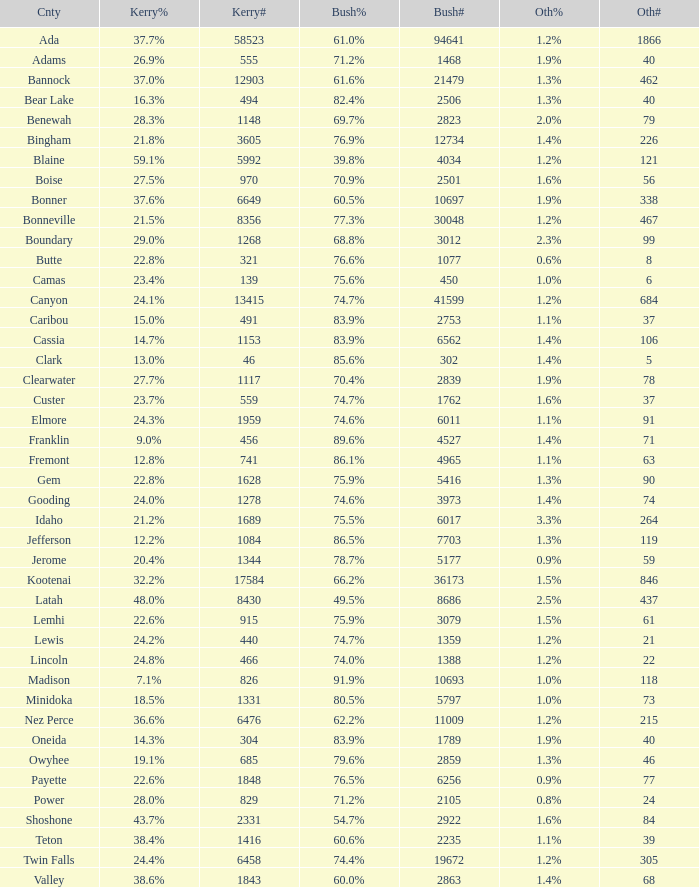What percentage of the votes in Oneida did Kerry win? 14.3%. 